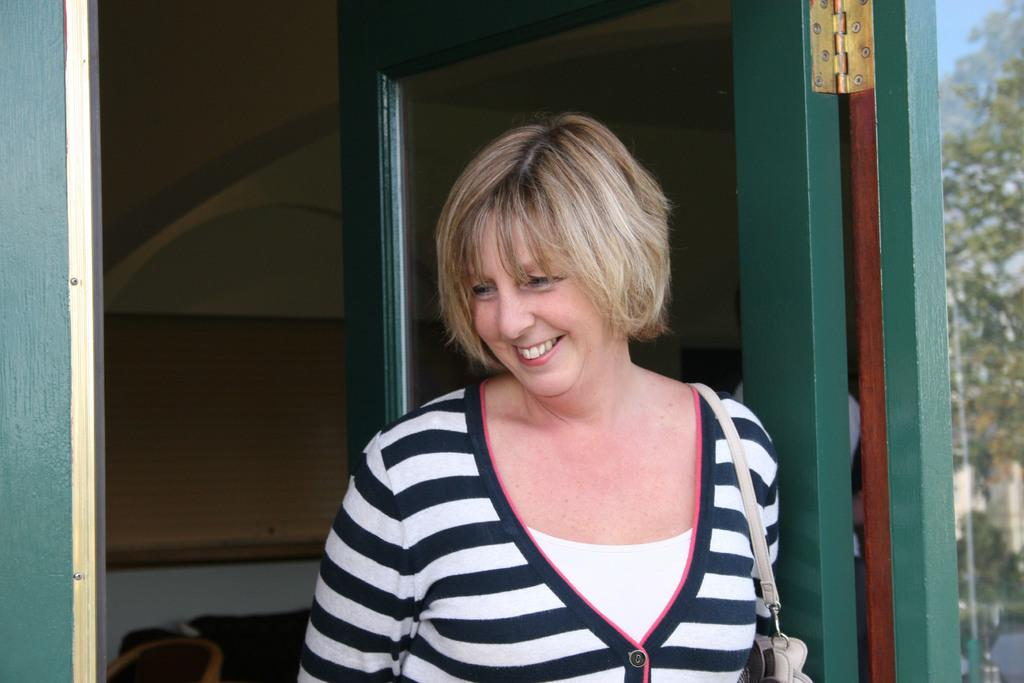What type of structure can be seen in the image? There is a wall in the image. Is there any entrance visible in the image? Yes, there is a door in the image. What is the woman in the image wearing? The woman is wearing a black and white dress. What can be seen on the right side of the image? There are trees on the right side of the image. What type of twist is the woman performing in the image? There is no twist being performed by the woman in the image; she is simply standing. What achievements has the woman accomplished, as depicted in the image? The image does not provide any information about the woman's achievements. 